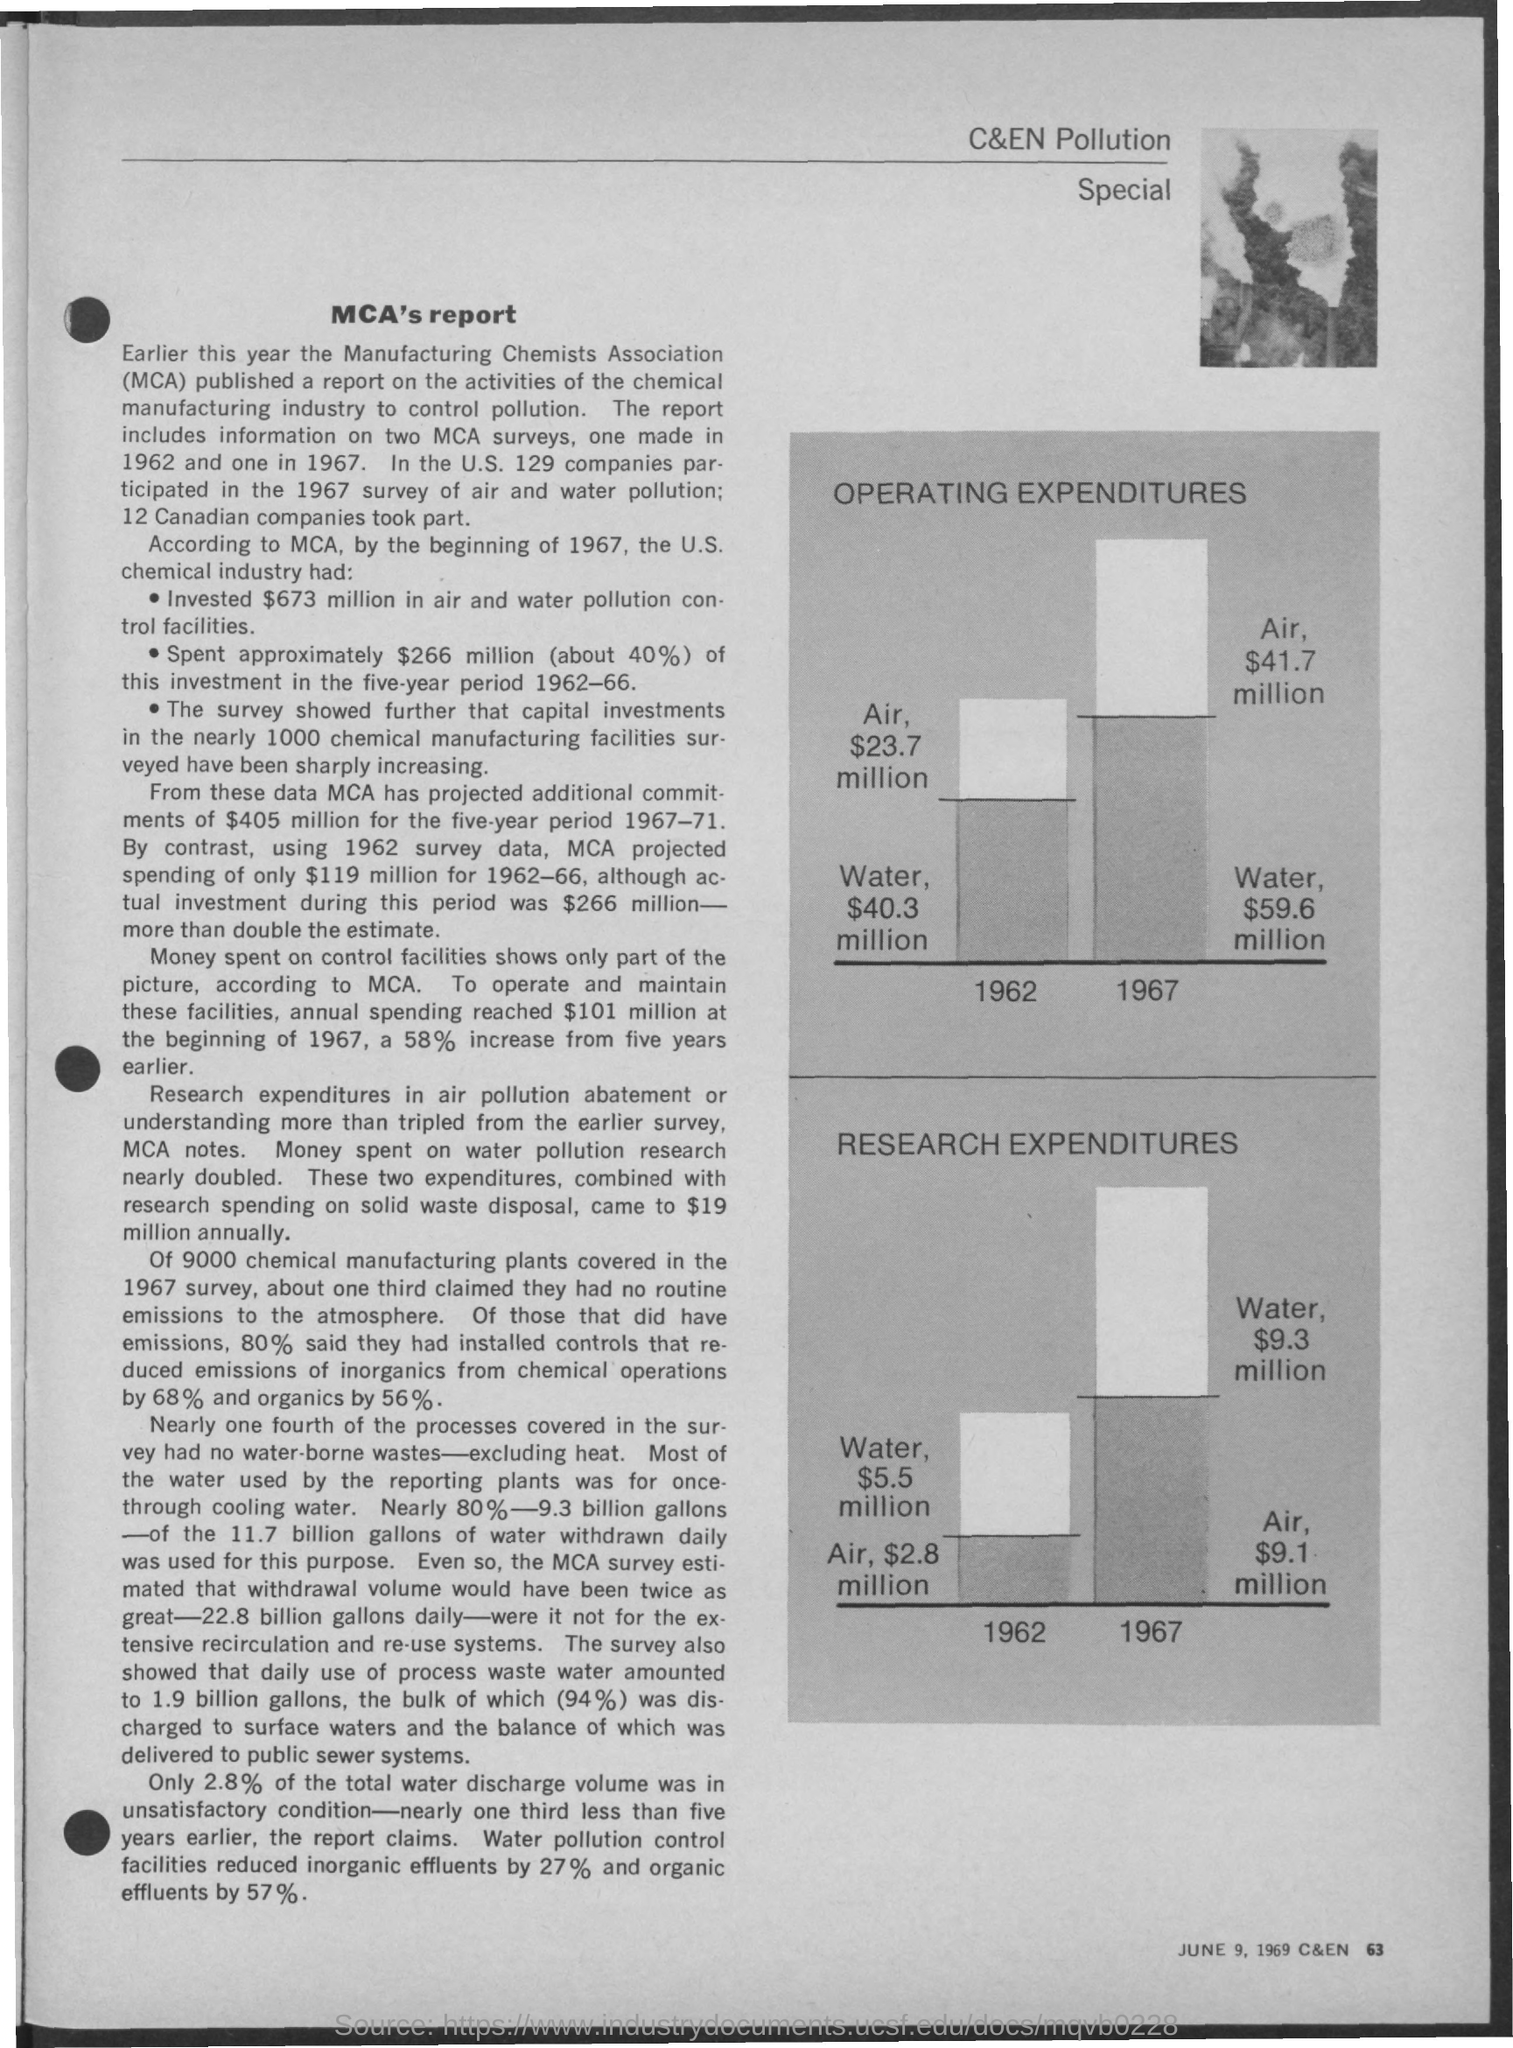What is the fullform of MCA?
Your response must be concise. Manufacturing Chemists Association. According to MCA, what is the amount invested by the U.S. chemical industry in air and water pollution control facilities?
Keep it short and to the point. $673 million. Which year, MCA surveys were conducted as per the document?
Your response must be concise. One made in 1962 and one in 1967. Which activities report is published by MCA earlier this year?
Provide a succinct answer. A report on the activities of the chemical manufacturing industry to control pollution. 